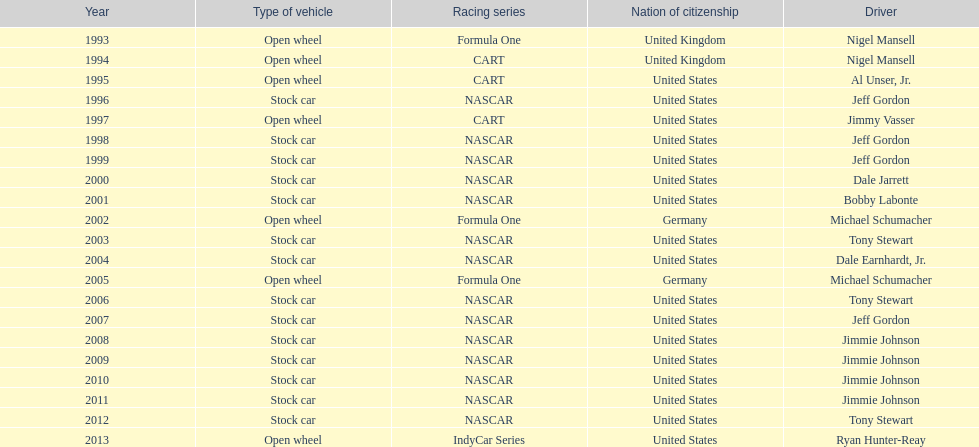Jimmy johnson won how many consecutive espy awards? 4. 